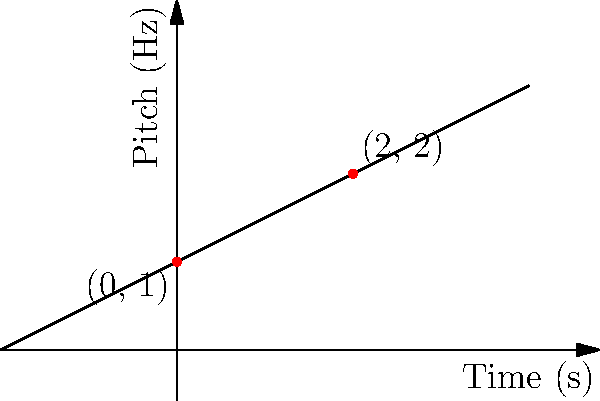In an electronic music composition, a synthesizer's pitch bend is represented by a linear function. Given that the pitch starts at 1 Hz when the time is 0 seconds and reaches 2 Hz after 2 seconds, determine the equation of the line representing this pitch bend in the form $y = mx + b$, where $y$ is the pitch in Hz and $x$ is the time in seconds. To find the equation of the line, we'll follow these steps:

1) We have two points: (0, 1) and (2, 2)

2) Calculate the slope (m) using the point-slope formula:
   $m = \frac{y_2 - y_1}{x_2 - x_1} = \frac{2 - 1}{2 - 0} = \frac{1}{2} = 0.5$

3) Use the point-slope form of a line with the point (0, 1):
   $y - y_1 = m(x - x_1)$
   $y - 1 = 0.5(x - 0)$

4) Simplify:
   $y - 1 = 0.5x$

5) Solve for y to get the slope-intercept form:
   $y = 0.5x + 1$

Therefore, the equation of the line representing the pitch bend is $y = 0.5x + 1$, where $y$ is the pitch in Hz and $x$ is the time in seconds.
Answer: $y = 0.5x + 1$ 